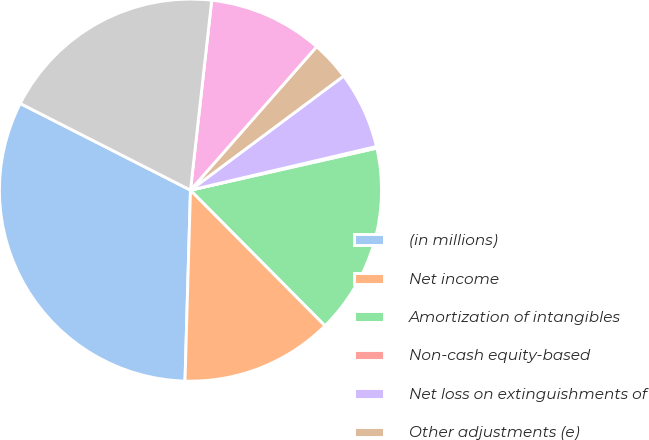Convert chart. <chart><loc_0><loc_0><loc_500><loc_500><pie_chart><fcel>(in millions)<fcel>Net income<fcel>Amortization of intangibles<fcel>Non-cash equity-based<fcel>Net loss on extinguishments of<fcel>Other adjustments (e)<fcel>Aggregate adjustment for<fcel>Non-GAAP net income (g)<nl><fcel>32.04%<fcel>12.9%<fcel>16.09%<fcel>0.14%<fcel>6.52%<fcel>3.33%<fcel>9.71%<fcel>19.28%<nl></chart> 